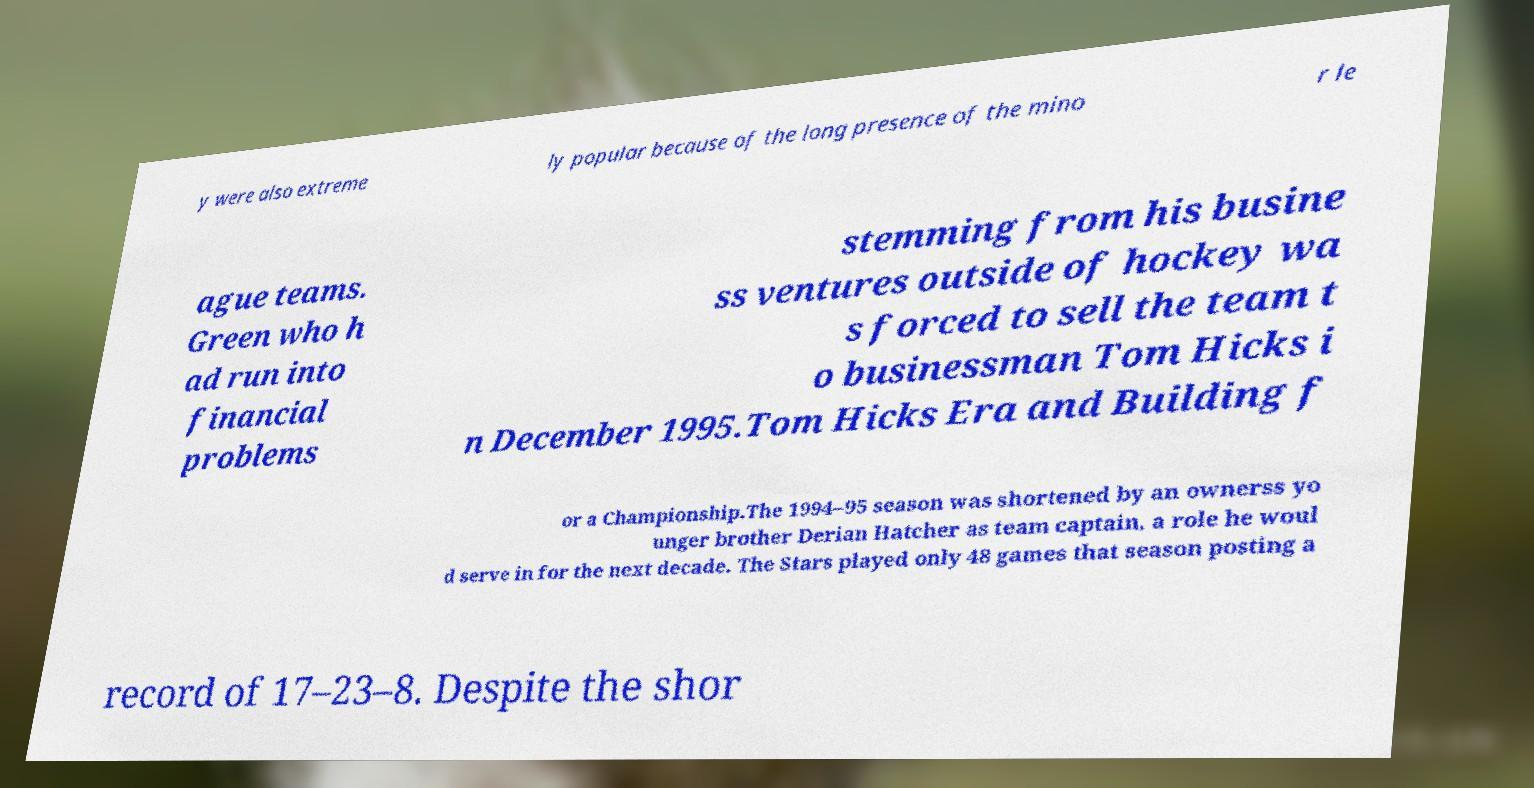There's text embedded in this image that I need extracted. Can you transcribe it verbatim? y were also extreme ly popular because of the long presence of the mino r le ague teams. Green who h ad run into financial problems stemming from his busine ss ventures outside of hockey wa s forced to sell the team t o businessman Tom Hicks i n December 1995.Tom Hicks Era and Building f or a Championship.The 1994–95 season was shortened by an ownerss yo unger brother Derian Hatcher as team captain, a role he woul d serve in for the next decade. The Stars played only 48 games that season posting a record of 17–23–8. Despite the shor 